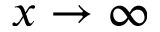<formula> <loc_0><loc_0><loc_500><loc_500>x \rightarrow \infty</formula> 